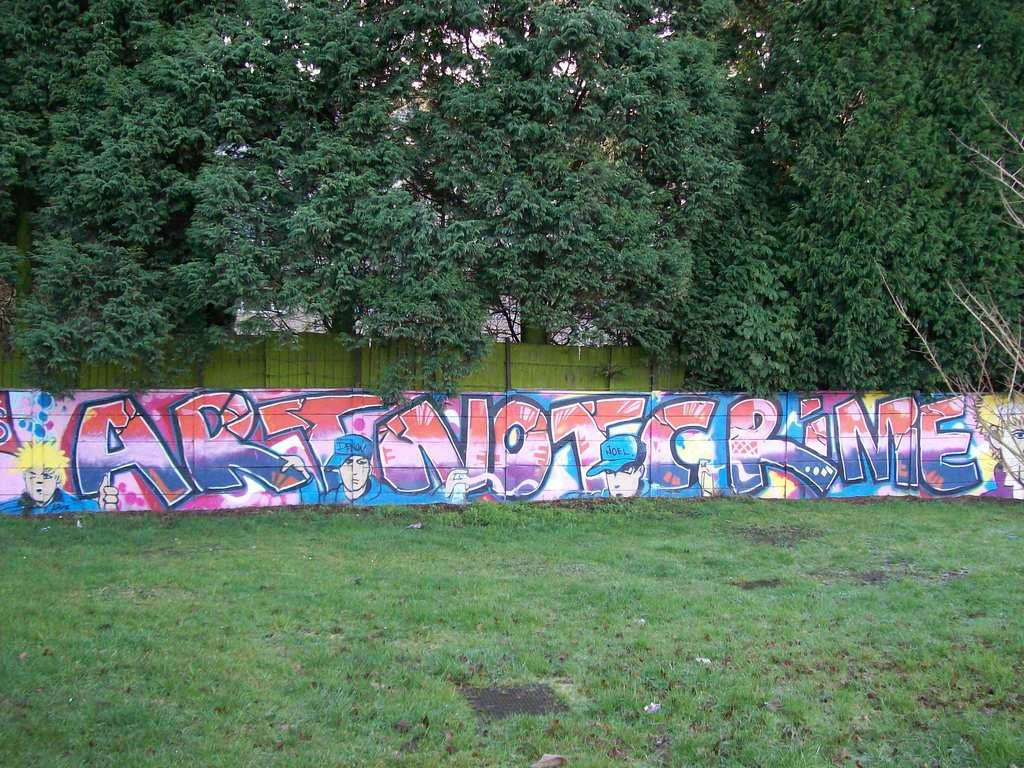What type of vegetation is visible in the foreground of the image? There is green grass in the foreground of the image. What can be seen hanging on the wall in the image? There is a painting on the wall in the image. What type of natural scenery is visible in the background of the image? There are trees in the background of the image. What type of bedroom furniture is visible in the image? There is no bedroom furniture present in the image. What things are being done by the self in the image? The concept of "self" is not applicable in this image, as it does not depict a person or any actions being performed. 